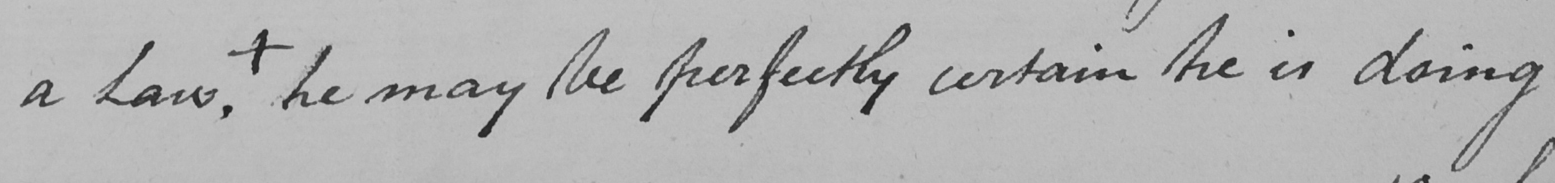Transcribe the text shown in this historical manuscript line. a Law , he may be perfectly certain he is doing 